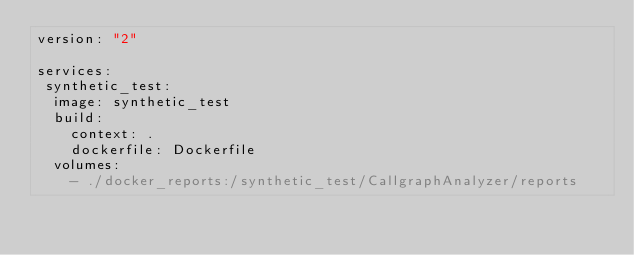<code> <loc_0><loc_0><loc_500><loc_500><_YAML_>version: "2"

services:
 synthetic_test:
  image: synthetic_test
  build:
    context: .
    dockerfile: Dockerfile
  volumes:
    - ./docker_reports:/synthetic_test/CallgraphAnalyzer/reports</code> 